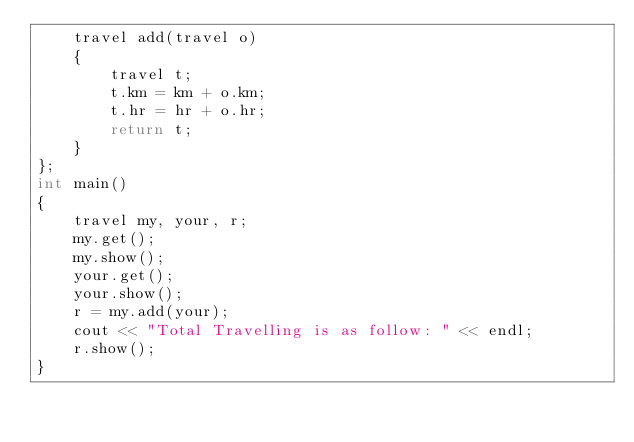Convert code to text. <code><loc_0><loc_0><loc_500><loc_500><_C++_>    travel add(travel o)
    {
        travel t;
        t.km = km + o.km;
        t.hr = hr + o.hr;
        return t;
    }
};
int main()
{
    travel my, your, r;
    my.get();
    my.show();
    your.get();
    your.show();
    r = my.add(your);
    cout << "Total Travelling is as follow: " << endl;
    r.show();
}
</code> 